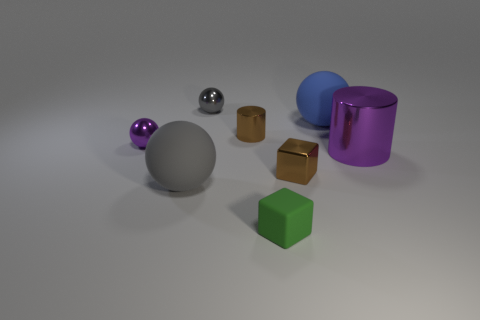Does the arrangement of the objects suggest anything to you? The objects are arranged in a somewhat spaced and orderly manner, which may imply a study of form and color contrasts—spheres against cubes, vibrant colors next to more muted tones. The arrangement might be intentional to create visual balance or for the purpose of a comparative study in a 3D modeling or rendering exercise.  Could there be a symbolic meaning behind the objects' placement? While the arrangement seems methodical, any symbolic meaning would be speculative. It could represent anything from the diversity of shapes and materials existing harmoniously to a more abstract concept of balance and order. The interpretation would largely depend on the viewer's perspective and possibly the artist's intent. 